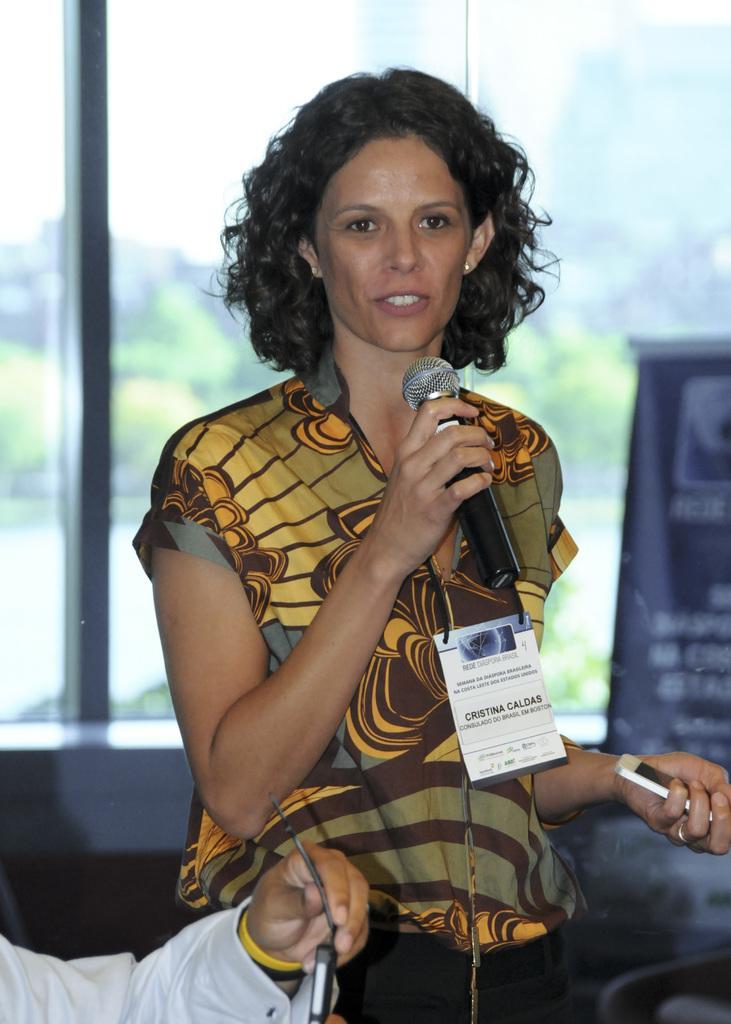How would you summarize this image in a sentence or two? In this image I can see a person wearing the yellow and coffee color dress and she is holding the mic and also a mobile. In the front of her there is a person's hand with white dress. In the back there is a banner and the window. Through the window I can see trees and the sky. 